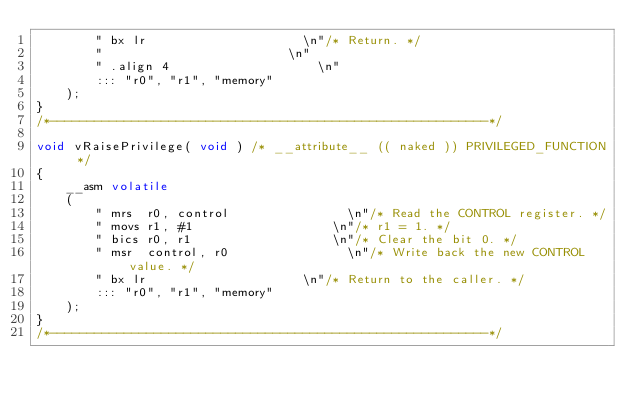Convert code to text. <code><loc_0><loc_0><loc_500><loc_500><_C_>        "	bx lr											\n"/* Return. */
        "													\n"
        "	.align 4										\n"
        ::: "r0", "r1", "memory"
    );
}
/*-----------------------------------------------------------*/

void vRaisePrivilege( void ) /* __attribute__ (( naked )) PRIVILEGED_FUNCTION */
{
    __asm volatile
    (
        "	mrs  r0, control								\n"/* Read the CONTROL register. */
        "	movs r1, #1										\n"/* r1 = 1. */
        "	bics r0, r1										\n"/* Clear the bit 0. */
        "	msr  control, r0								\n"/* Write back the new CONTROL value. */
        "	bx lr											\n"/* Return to the caller. */
        ::: "r0", "r1", "memory"
    );
}
/*-----------------------------------------------------------*/
</code> 